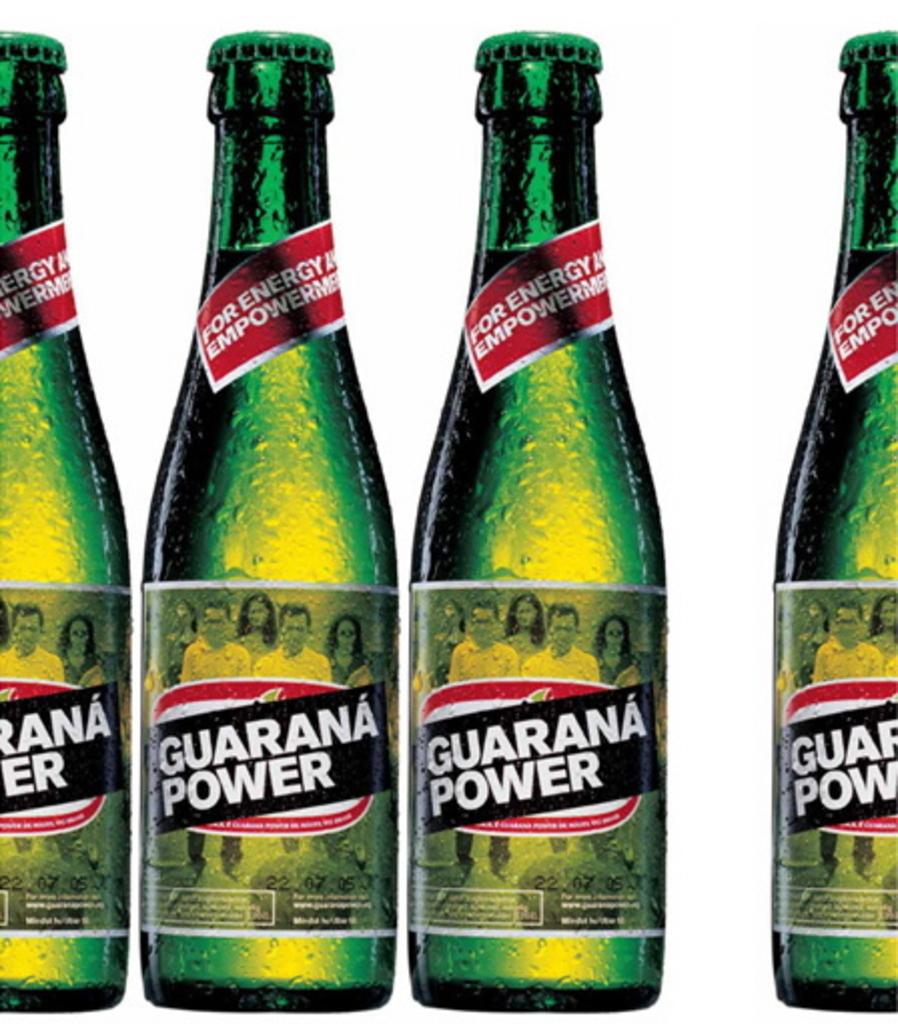What is the name of this drink?
Provide a short and direct response. Guarana power. What is the drink for?
Give a very brief answer. Energy. 